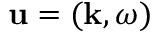<formula> <loc_0><loc_0><loc_500><loc_500>u = ( k , \omega )</formula> 